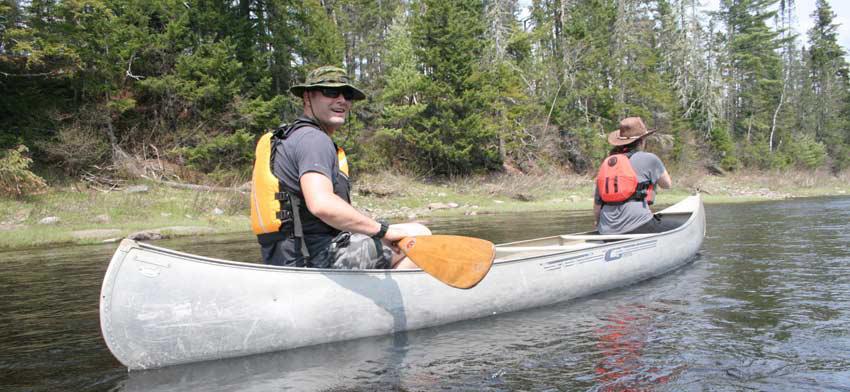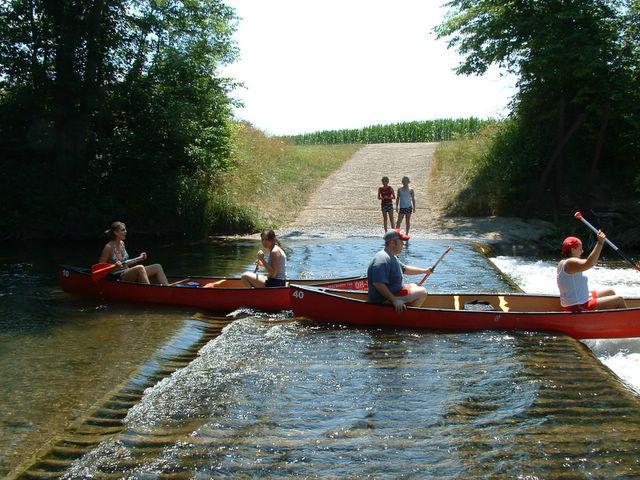The first image is the image on the left, the second image is the image on the right. Assess this claim about the two images: "One image contains only canoes that are red.". Correct or not? Answer yes or no. Yes. 